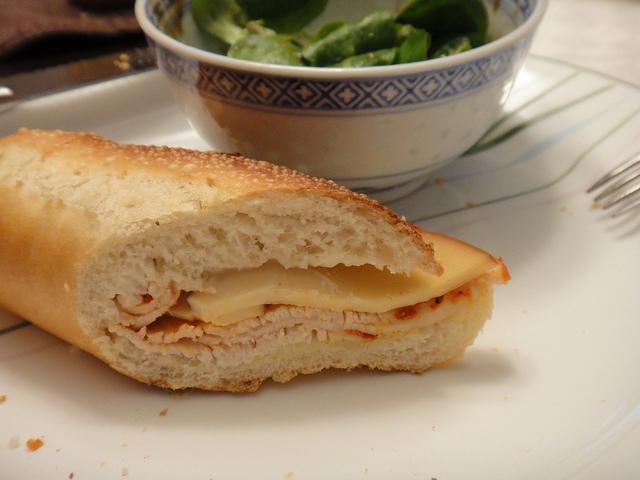Is the caption "The sandwich is at the edge of the bowl." a true representation of the image?
Answer yes or no. No. 